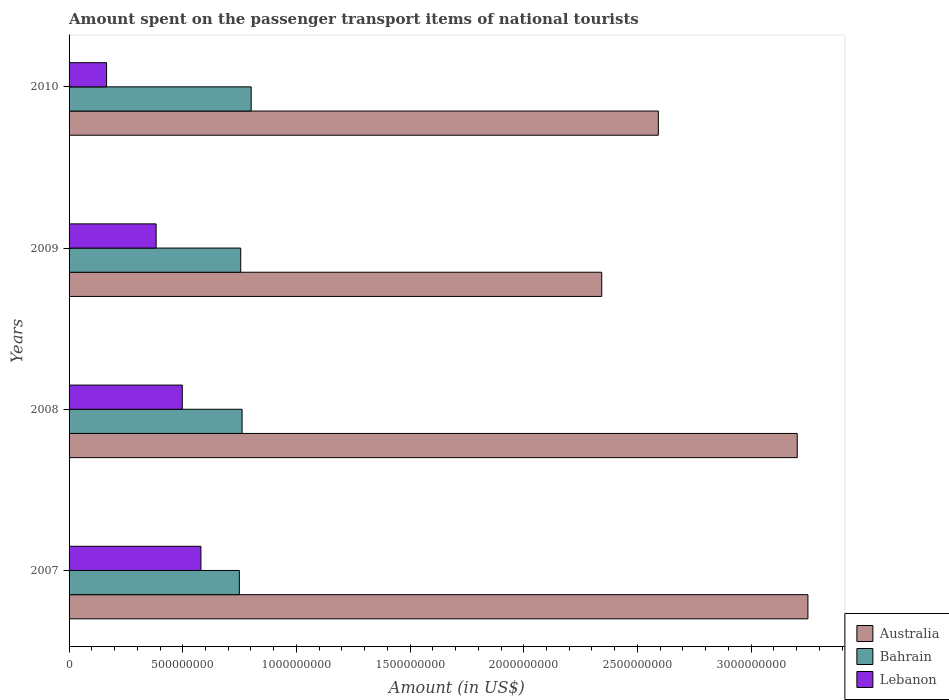How many groups of bars are there?
Your answer should be very brief. 4. How many bars are there on the 2nd tick from the top?
Provide a short and direct response. 3. What is the amount spent on the passenger transport items of national tourists in Australia in 2007?
Make the answer very short. 3.25e+09. Across all years, what is the maximum amount spent on the passenger transport items of national tourists in Lebanon?
Your response must be concise. 5.80e+08. Across all years, what is the minimum amount spent on the passenger transport items of national tourists in Bahrain?
Ensure brevity in your answer.  7.49e+08. In which year was the amount spent on the passenger transport items of national tourists in Lebanon maximum?
Your response must be concise. 2007. What is the total amount spent on the passenger transport items of national tourists in Australia in the graph?
Your answer should be very brief. 1.14e+1. What is the difference between the amount spent on the passenger transport items of national tourists in Bahrain in 2008 and that in 2010?
Ensure brevity in your answer.  -4.00e+07. What is the difference between the amount spent on the passenger transport items of national tourists in Lebanon in 2009 and the amount spent on the passenger transport items of national tourists in Australia in 2008?
Give a very brief answer. -2.82e+09. What is the average amount spent on the passenger transport items of national tourists in Bahrain per year?
Give a very brief answer. 7.66e+08. In the year 2008, what is the difference between the amount spent on the passenger transport items of national tourists in Bahrain and amount spent on the passenger transport items of national tourists in Australia?
Keep it short and to the point. -2.44e+09. What is the ratio of the amount spent on the passenger transport items of national tourists in Australia in 2007 to that in 2009?
Your response must be concise. 1.39. Is the difference between the amount spent on the passenger transport items of national tourists in Bahrain in 2007 and 2010 greater than the difference between the amount spent on the passenger transport items of national tourists in Australia in 2007 and 2010?
Your response must be concise. No. What is the difference between the highest and the second highest amount spent on the passenger transport items of national tourists in Australia?
Keep it short and to the point. 4.70e+07. What is the difference between the highest and the lowest amount spent on the passenger transport items of national tourists in Lebanon?
Give a very brief answer. 4.15e+08. Is the sum of the amount spent on the passenger transport items of national tourists in Australia in 2007 and 2009 greater than the maximum amount spent on the passenger transport items of national tourists in Bahrain across all years?
Your response must be concise. Yes. What does the 1st bar from the top in 2010 represents?
Your answer should be compact. Lebanon. What does the 3rd bar from the bottom in 2010 represents?
Keep it short and to the point. Lebanon. Is it the case that in every year, the sum of the amount spent on the passenger transport items of national tourists in Australia and amount spent on the passenger transport items of national tourists in Lebanon is greater than the amount spent on the passenger transport items of national tourists in Bahrain?
Give a very brief answer. Yes. How many bars are there?
Your answer should be very brief. 12. Are all the bars in the graph horizontal?
Make the answer very short. Yes. How many years are there in the graph?
Give a very brief answer. 4. What is the difference between two consecutive major ticks on the X-axis?
Your response must be concise. 5.00e+08. Are the values on the major ticks of X-axis written in scientific E-notation?
Give a very brief answer. No. Does the graph contain any zero values?
Give a very brief answer. No. How many legend labels are there?
Provide a succinct answer. 3. How are the legend labels stacked?
Give a very brief answer. Vertical. What is the title of the graph?
Give a very brief answer. Amount spent on the passenger transport items of national tourists. What is the label or title of the Y-axis?
Your answer should be very brief. Years. What is the Amount (in US$) of Australia in 2007?
Keep it short and to the point. 3.25e+09. What is the Amount (in US$) in Bahrain in 2007?
Your response must be concise. 7.49e+08. What is the Amount (in US$) of Lebanon in 2007?
Provide a succinct answer. 5.80e+08. What is the Amount (in US$) of Australia in 2008?
Your answer should be very brief. 3.20e+09. What is the Amount (in US$) of Bahrain in 2008?
Offer a terse response. 7.61e+08. What is the Amount (in US$) in Lebanon in 2008?
Offer a very short reply. 4.98e+08. What is the Amount (in US$) of Australia in 2009?
Give a very brief answer. 2.34e+09. What is the Amount (in US$) of Bahrain in 2009?
Ensure brevity in your answer.  7.55e+08. What is the Amount (in US$) of Lebanon in 2009?
Ensure brevity in your answer.  3.83e+08. What is the Amount (in US$) of Australia in 2010?
Your answer should be compact. 2.59e+09. What is the Amount (in US$) in Bahrain in 2010?
Provide a short and direct response. 8.01e+08. What is the Amount (in US$) of Lebanon in 2010?
Your response must be concise. 1.65e+08. Across all years, what is the maximum Amount (in US$) of Australia?
Ensure brevity in your answer.  3.25e+09. Across all years, what is the maximum Amount (in US$) in Bahrain?
Your response must be concise. 8.01e+08. Across all years, what is the maximum Amount (in US$) of Lebanon?
Offer a terse response. 5.80e+08. Across all years, what is the minimum Amount (in US$) of Australia?
Your answer should be very brief. 2.34e+09. Across all years, what is the minimum Amount (in US$) of Bahrain?
Give a very brief answer. 7.49e+08. Across all years, what is the minimum Amount (in US$) in Lebanon?
Your response must be concise. 1.65e+08. What is the total Amount (in US$) of Australia in the graph?
Your answer should be compact. 1.14e+1. What is the total Amount (in US$) in Bahrain in the graph?
Offer a very short reply. 3.07e+09. What is the total Amount (in US$) in Lebanon in the graph?
Offer a terse response. 1.63e+09. What is the difference between the Amount (in US$) of Australia in 2007 and that in 2008?
Ensure brevity in your answer.  4.70e+07. What is the difference between the Amount (in US$) in Bahrain in 2007 and that in 2008?
Offer a very short reply. -1.20e+07. What is the difference between the Amount (in US$) of Lebanon in 2007 and that in 2008?
Provide a short and direct response. 8.20e+07. What is the difference between the Amount (in US$) in Australia in 2007 and that in 2009?
Your response must be concise. 9.07e+08. What is the difference between the Amount (in US$) of Bahrain in 2007 and that in 2009?
Your response must be concise. -6.00e+06. What is the difference between the Amount (in US$) in Lebanon in 2007 and that in 2009?
Offer a very short reply. 1.97e+08. What is the difference between the Amount (in US$) in Australia in 2007 and that in 2010?
Offer a terse response. 6.58e+08. What is the difference between the Amount (in US$) in Bahrain in 2007 and that in 2010?
Make the answer very short. -5.20e+07. What is the difference between the Amount (in US$) of Lebanon in 2007 and that in 2010?
Offer a very short reply. 4.15e+08. What is the difference between the Amount (in US$) in Australia in 2008 and that in 2009?
Provide a short and direct response. 8.60e+08. What is the difference between the Amount (in US$) in Bahrain in 2008 and that in 2009?
Offer a terse response. 6.00e+06. What is the difference between the Amount (in US$) of Lebanon in 2008 and that in 2009?
Keep it short and to the point. 1.15e+08. What is the difference between the Amount (in US$) of Australia in 2008 and that in 2010?
Give a very brief answer. 6.11e+08. What is the difference between the Amount (in US$) in Bahrain in 2008 and that in 2010?
Keep it short and to the point. -4.00e+07. What is the difference between the Amount (in US$) in Lebanon in 2008 and that in 2010?
Your answer should be compact. 3.33e+08. What is the difference between the Amount (in US$) of Australia in 2009 and that in 2010?
Offer a very short reply. -2.49e+08. What is the difference between the Amount (in US$) in Bahrain in 2009 and that in 2010?
Your answer should be compact. -4.60e+07. What is the difference between the Amount (in US$) in Lebanon in 2009 and that in 2010?
Make the answer very short. 2.18e+08. What is the difference between the Amount (in US$) in Australia in 2007 and the Amount (in US$) in Bahrain in 2008?
Give a very brief answer. 2.49e+09. What is the difference between the Amount (in US$) of Australia in 2007 and the Amount (in US$) of Lebanon in 2008?
Your answer should be compact. 2.75e+09. What is the difference between the Amount (in US$) in Bahrain in 2007 and the Amount (in US$) in Lebanon in 2008?
Offer a terse response. 2.51e+08. What is the difference between the Amount (in US$) of Australia in 2007 and the Amount (in US$) of Bahrain in 2009?
Offer a terse response. 2.50e+09. What is the difference between the Amount (in US$) of Australia in 2007 and the Amount (in US$) of Lebanon in 2009?
Provide a succinct answer. 2.87e+09. What is the difference between the Amount (in US$) of Bahrain in 2007 and the Amount (in US$) of Lebanon in 2009?
Provide a succinct answer. 3.66e+08. What is the difference between the Amount (in US$) of Australia in 2007 and the Amount (in US$) of Bahrain in 2010?
Your answer should be very brief. 2.45e+09. What is the difference between the Amount (in US$) of Australia in 2007 and the Amount (in US$) of Lebanon in 2010?
Your answer should be very brief. 3.08e+09. What is the difference between the Amount (in US$) in Bahrain in 2007 and the Amount (in US$) in Lebanon in 2010?
Give a very brief answer. 5.84e+08. What is the difference between the Amount (in US$) of Australia in 2008 and the Amount (in US$) of Bahrain in 2009?
Keep it short and to the point. 2.45e+09. What is the difference between the Amount (in US$) of Australia in 2008 and the Amount (in US$) of Lebanon in 2009?
Keep it short and to the point. 2.82e+09. What is the difference between the Amount (in US$) in Bahrain in 2008 and the Amount (in US$) in Lebanon in 2009?
Give a very brief answer. 3.78e+08. What is the difference between the Amount (in US$) of Australia in 2008 and the Amount (in US$) of Bahrain in 2010?
Offer a very short reply. 2.40e+09. What is the difference between the Amount (in US$) in Australia in 2008 and the Amount (in US$) in Lebanon in 2010?
Offer a very short reply. 3.04e+09. What is the difference between the Amount (in US$) of Bahrain in 2008 and the Amount (in US$) of Lebanon in 2010?
Provide a short and direct response. 5.96e+08. What is the difference between the Amount (in US$) of Australia in 2009 and the Amount (in US$) of Bahrain in 2010?
Offer a very short reply. 1.54e+09. What is the difference between the Amount (in US$) of Australia in 2009 and the Amount (in US$) of Lebanon in 2010?
Your response must be concise. 2.18e+09. What is the difference between the Amount (in US$) in Bahrain in 2009 and the Amount (in US$) in Lebanon in 2010?
Offer a terse response. 5.90e+08. What is the average Amount (in US$) in Australia per year?
Make the answer very short. 2.85e+09. What is the average Amount (in US$) of Bahrain per year?
Make the answer very short. 7.66e+08. What is the average Amount (in US$) in Lebanon per year?
Ensure brevity in your answer.  4.06e+08. In the year 2007, what is the difference between the Amount (in US$) in Australia and Amount (in US$) in Bahrain?
Provide a succinct answer. 2.50e+09. In the year 2007, what is the difference between the Amount (in US$) in Australia and Amount (in US$) in Lebanon?
Your answer should be very brief. 2.67e+09. In the year 2007, what is the difference between the Amount (in US$) in Bahrain and Amount (in US$) in Lebanon?
Your answer should be very brief. 1.69e+08. In the year 2008, what is the difference between the Amount (in US$) of Australia and Amount (in US$) of Bahrain?
Your response must be concise. 2.44e+09. In the year 2008, what is the difference between the Amount (in US$) in Australia and Amount (in US$) in Lebanon?
Your answer should be very brief. 2.70e+09. In the year 2008, what is the difference between the Amount (in US$) in Bahrain and Amount (in US$) in Lebanon?
Ensure brevity in your answer.  2.63e+08. In the year 2009, what is the difference between the Amount (in US$) of Australia and Amount (in US$) of Bahrain?
Your response must be concise. 1.59e+09. In the year 2009, what is the difference between the Amount (in US$) in Australia and Amount (in US$) in Lebanon?
Keep it short and to the point. 1.96e+09. In the year 2009, what is the difference between the Amount (in US$) in Bahrain and Amount (in US$) in Lebanon?
Your response must be concise. 3.72e+08. In the year 2010, what is the difference between the Amount (in US$) of Australia and Amount (in US$) of Bahrain?
Your answer should be compact. 1.79e+09. In the year 2010, what is the difference between the Amount (in US$) of Australia and Amount (in US$) of Lebanon?
Your answer should be compact. 2.43e+09. In the year 2010, what is the difference between the Amount (in US$) of Bahrain and Amount (in US$) of Lebanon?
Provide a succinct answer. 6.36e+08. What is the ratio of the Amount (in US$) in Australia in 2007 to that in 2008?
Provide a succinct answer. 1.01. What is the ratio of the Amount (in US$) in Bahrain in 2007 to that in 2008?
Your answer should be compact. 0.98. What is the ratio of the Amount (in US$) in Lebanon in 2007 to that in 2008?
Offer a very short reply. 1.16. What is the ratio of the Amount (in US$) of Australia in 2007 to that in 2009?
Give a very brief answer. 1.39. What is the ratio of the Amount (in US$) in Lebanon in 2007 to that in 2009?
Offer a terse response. 1.51. What is the ratio of the Amount (in US$) of Australia in 2007 to that in 2010?
Provide a succinct answer. 1.25. What is the ratio of the Amount (in US$) in Bahrain in 2007 to that in 2010?
Your answer should be very brief. 0.94. What is the ratio of the Amount (in US$) of Lebanon in 2007 to that in 2010?
Keep it short and to the point. 3.52. What is the ratio of the Amount (in US$) of Australia in 2008 to that in 2009?
Ensure brevity in your answer.  1.37. What is the ratio of the Amount (in US$) of Bahrain in 2008 to that in 2009?
Ensure brevity in your answer.  1.01. What is the ratio of the Amount (in US$) in Lebanon in 2008 to that in 2009?
Give a very brief answer. 1.3. What is the ratio of the Amount (in US$) of Australia in 2008 to that in 2010?
Your answer should be compact. 1.24. What is the ratio of the Amount (in US$) of Bahrain in 2008 to that in 2010?
Your answer should be very brief. 0.95. What is the ratio of the Amount (in US$) of Lebanon in 2008 to that in 2010?
Provide a short and direct response. 3.02. What is the ratio of the Amount (in US$) of Australia in 2009 to that in 2010?
Provide a short and direct response. 0.9. What is the ratio of the Amount (in US$) in Bahrain in 2009 to that in 2010?
Keep it short and to the point. 0.94. What is the ratio of the Amount (in US$) of Lebanon in 2009 to that in 2010?
Give a very brief answer. 2.32. What is the difference between the highest and the second highest Amount (in US$) of Australia?
Give a very brief answer. 4.70e+07. What is the difference between the highest and the second highest Amount (in US$) of Bahrain?
Make the answer very short. 4.00e+07. What is the difference between the highest and the second highest Amount (in US$) of Lebanon?
Your response must be concise. 8.20e+07. What is the difference between the highest and the lowest Amount (in US$) in Australia?
Your answer should be very brief. 9.07e+08. What is the difference between the highest and the lowest Amount (in US$) in Bahrain?
Offer a very short reply. 5.20e+07. What is the difference between the highest and the lowest Amount (in US$) in Lebanon?
Give a very brief answer. 4.15e+08. 